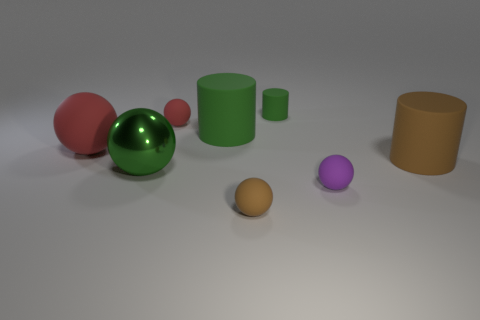Subtract all yellow balls. Subtract all gray cubes. How many balls are left? 5 Subtract all spheres. How many objects are left? 3 Subtract all small balls. Subtract all metal objects. How many objects are left? 4 Add 4 small green rubber cylinders. How many small green rubber cylinders are left? 5 Add 2 small purple spheres. How many small purple spheres exist? 3 Subtract 0 blue cylinders. How many objects are left? 8 